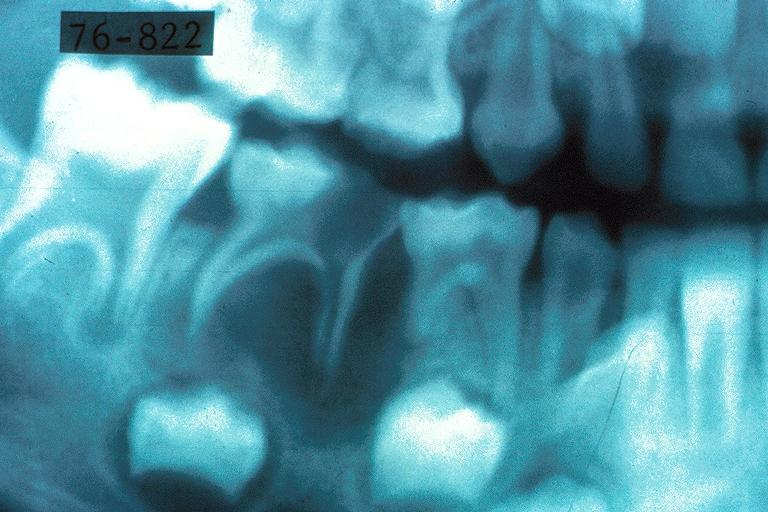does this image show turners tooth?
Answer the question using a single word or phrase. Yes 